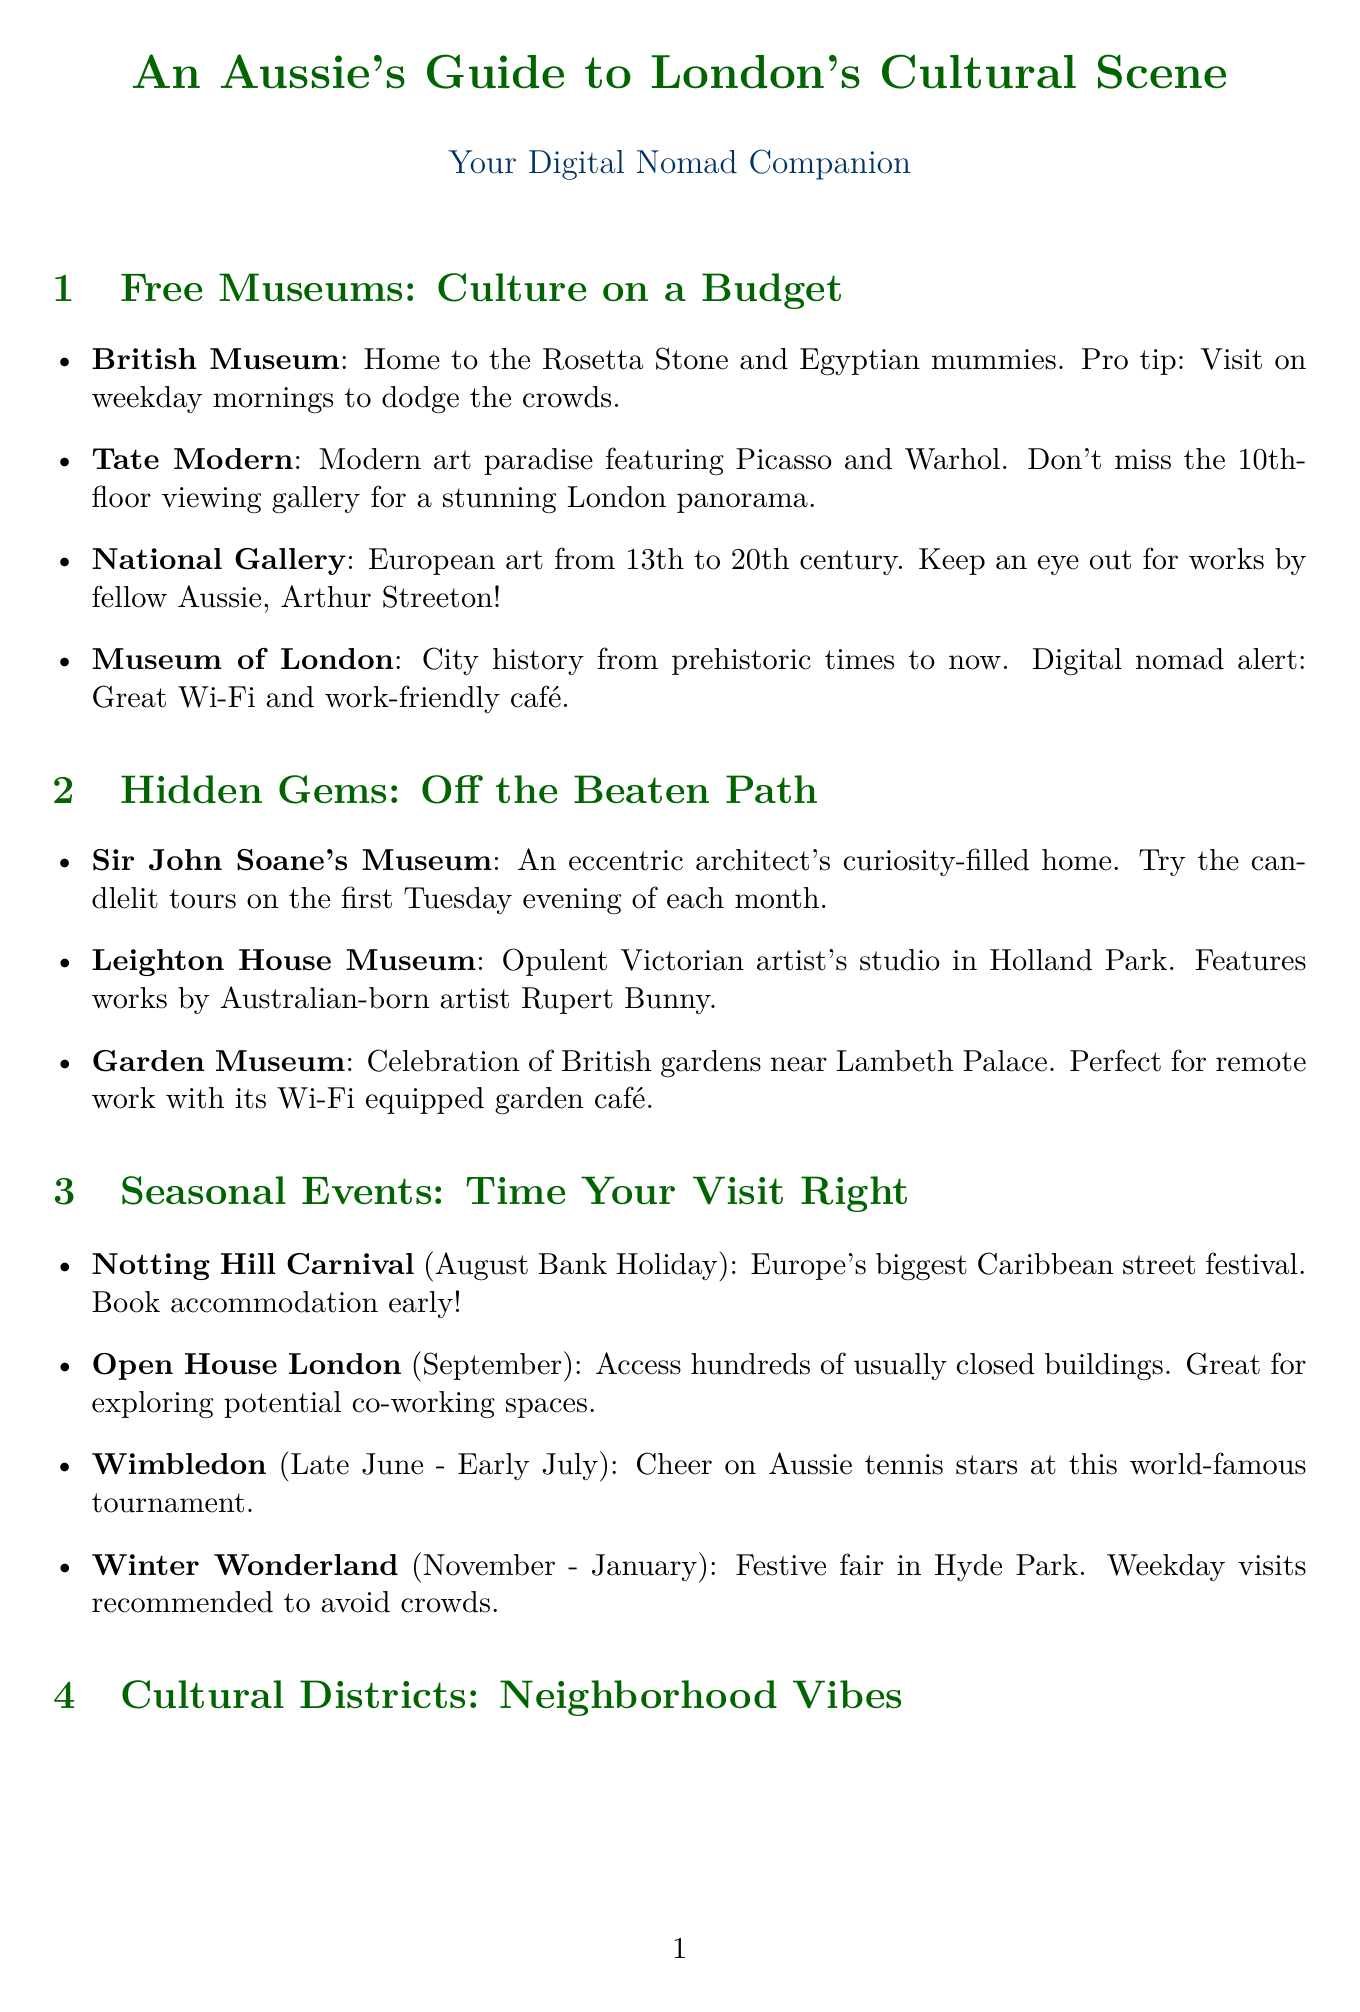What is the highlight of the Tate Modern? The highlight of the Tate Modern is modern and contemporary art, including works by Picasso and Warhol.
Answer: Modern and contemporary art When is the Notting Hill Carnival celebrated? The Notting Hill Carnival is celebrated on the August Bank Holiday weekend.
Answer: August Bank Holiday weekend What is a tip for visiting the Museum of London? A tip for visiting the Museum of London is that it has excellent free Wi-Fi and work-friendly spaces in the cafe.
Answer: Excellent free Wi-Fi and work-friendly spaces Which museum is located at Lincoln's Inn Fields? The museum located at Lincoln's Inn Fields is Sir John Soane's Museum.
Answer: Sir John Soane's Museum How many cultural districts are mentioned in the report? The report mentions three cultural districts: South Bank, Shoreditch, and West End.
Answer: Three What is the location of Keats House? The location of Keats House is Hampstead.
Answer: Hampstead What type of museum is the Hunterian Museum? The Hunterian Museum features medical and anatomical specimens.
Answer: Medical and anatomical specimens Which Australian artist's work is featured in the National Gallery? The National Gallery features works by Australian artist Arthur Streeton.
Answer: Arthur Streeton 